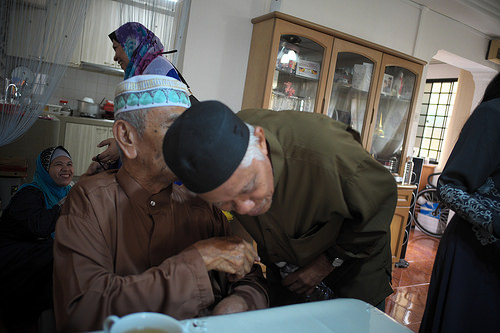<image>
Is there a first man in front of the second man? Yes. The first man is positioned in front of the second man, appearing closer to the camera viewpoint. 